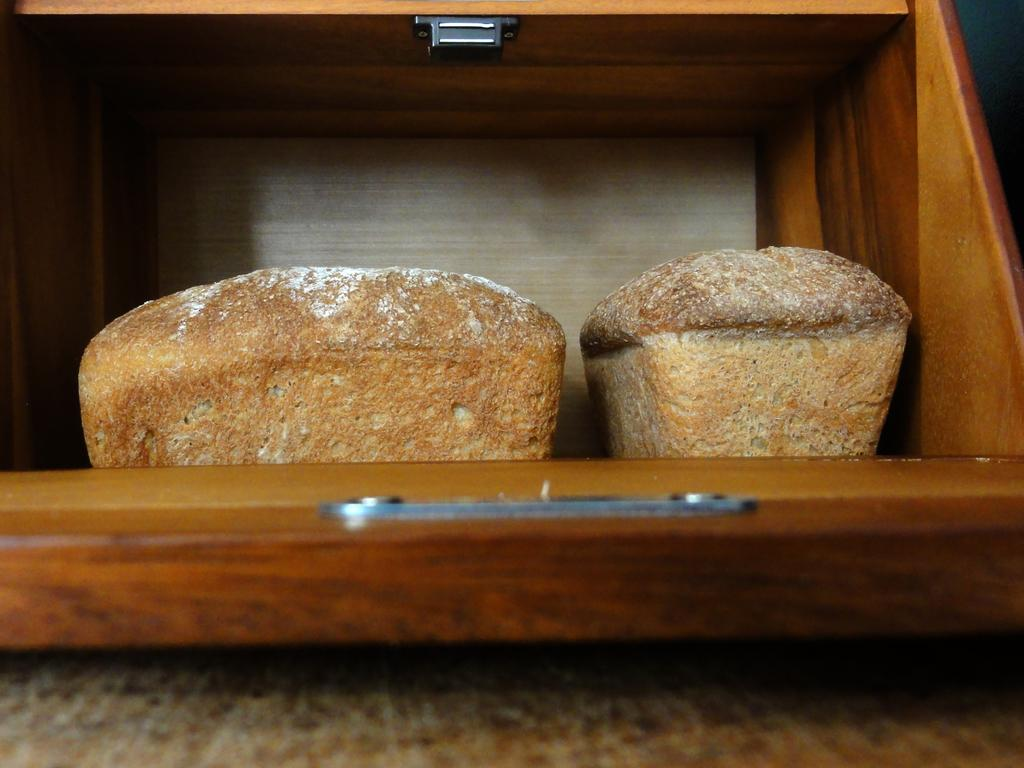What type of material is the wooden object made of in the image? The wooden object in the image is made of wood. What else can be seen in the image besides the wooden object? There are food items in the image. What type of crime is being committed in the image? There is no crime being committed in the image; it only features a wooden object and food items. How many birds are visible in the image? There are no birds present in the image. 